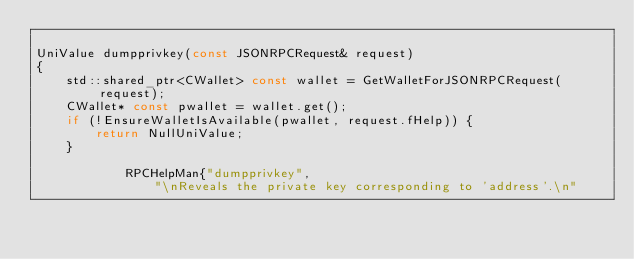Convert code to text. <code><loc_0><loc_0><loc_500><loc_500><_C++_>
UniValue dumpprivkey(const JSONRPCRequest& request)
{
    std::shared_ptr<CWallet> const wallet = GetWalletForJSONRPCRequest(request);
    CWallet* const pwallet = wallet.get();
    if (!EnsureWalletIsAvailable(pwallet, request.fHelp)) {
        return NullUniValue;
    }

            RPCHelpMan{"dumpprivkey",
                "\nReveals the private key corresponding to 'address'.\n"</code> 